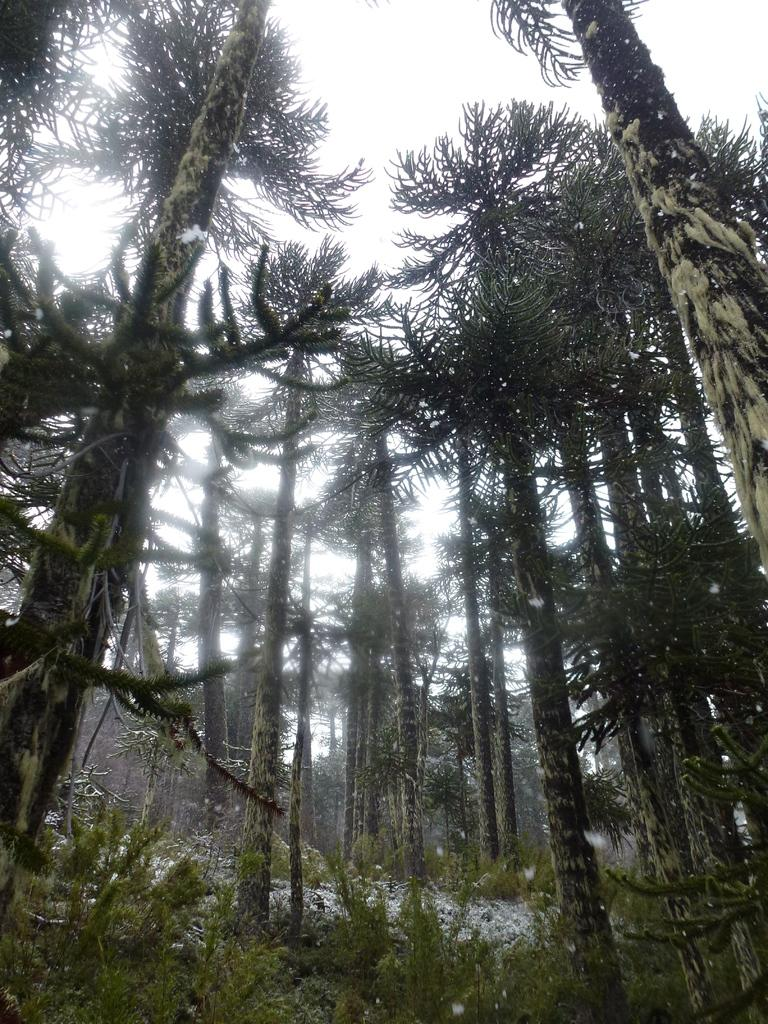What type of environment is depicted in the image? There is greenery visible in the image, suggesting a natural or outdoor setting. What type of surprise can be seen in the image? There is no surprise present in the image; it only features greenery. What type of current can be seen flowing through the image? There is no current present in the image; it only features greenery. 